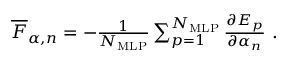Convert formula to latex. <formula><loc_0><loc_0><loc_500><loc_500>\begin{array} { r } { \overline { F } _ { \alpha , n } = - \frac { 1 } { N _ { M L P } } \sum _ { p = 1 } ^ { N _ { M L P } } \frac { \partial E _ { p } } { \partial \alpha _ { n } } \ . } \end{array}</formula> 